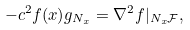Convert formula to latex. <formula><loc_0><loc_0><loc_500><loc_500>- c ^ { 2 } f ( x ) g _ { N _ { x } } = \nabla ^ { 2 } f | _ { N _ { x } \mathcal { F } } ,</formula> 